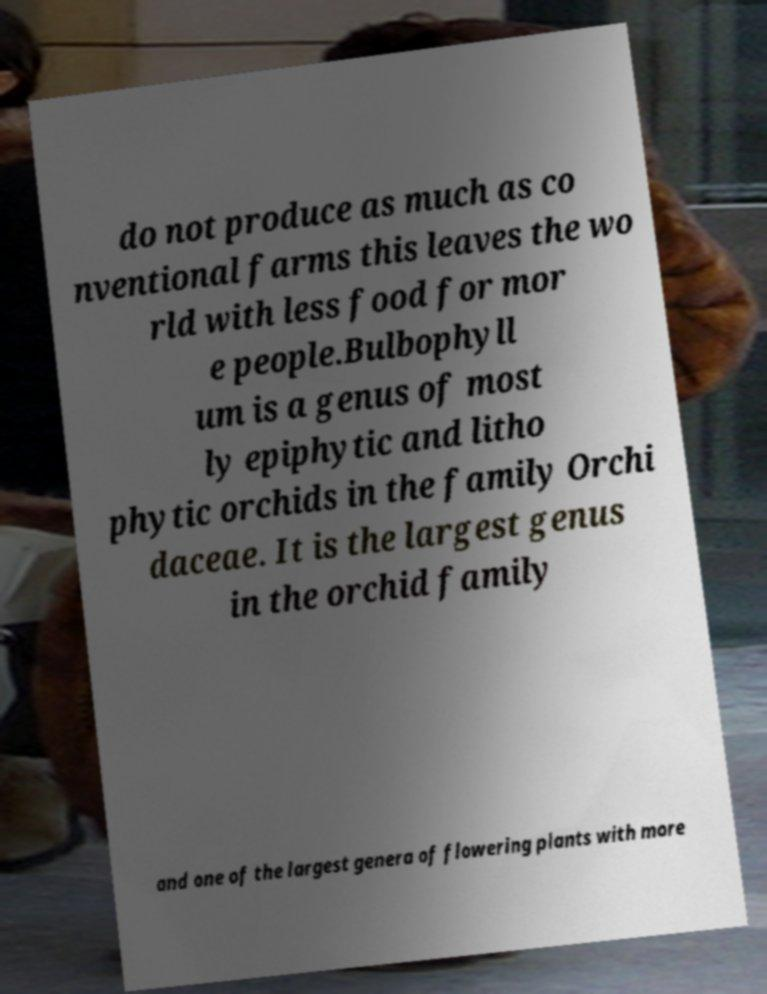Could you extract and type out the text from this image? do not produce as much as co nventional farms this leaves the wo rld with less food for mor e people.Bulbophyll um is a genus of most ly epiphytic and litho phytic orchids in the family Orchi daceae. It is the largest genus in the orchid family and one of the largest genera of flowering plants with more 